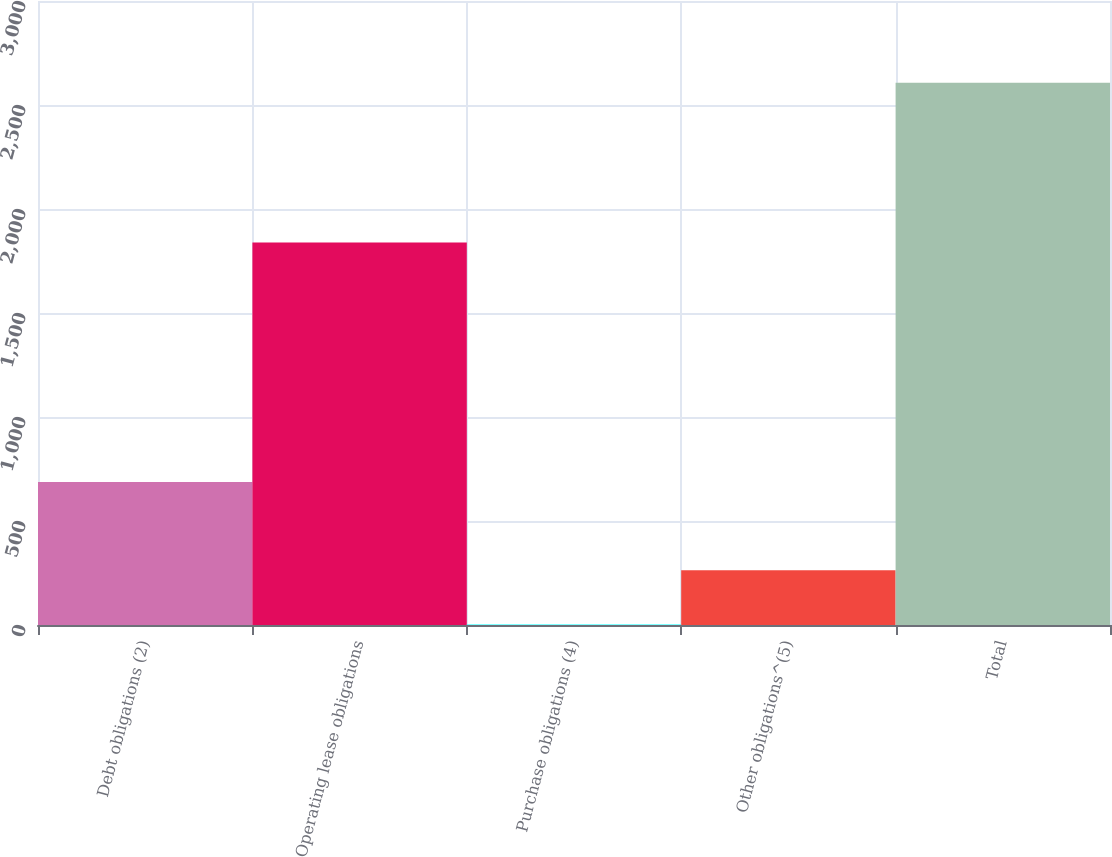Convert chart. <chart><loc_0><loc_0><loc_500><loc_500><bar_chart><fcel>Debt obligations (2)<fcel>Operating lease obligations<fcel>Purchase obligations (4)<fcel>Other obligations^(5)<fcel>Total<nl><fcel>687.5<fcel>1838.8<fcel>2.5<fcel>262.97<fcel>2607.2<nl></chart> 